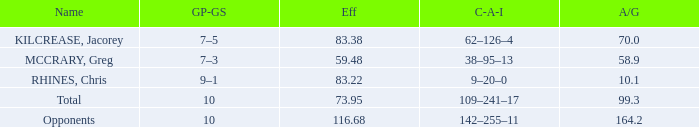What is the lowest effic with a 58.9 avg/g? 59.48. 